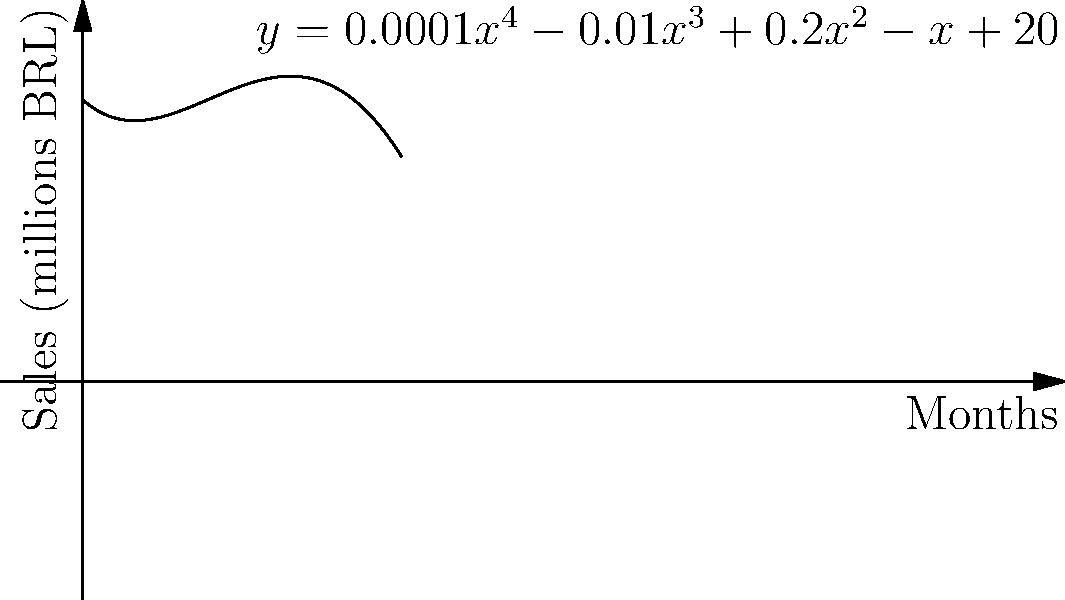As the marketing director overseeing the expansion in Brazil, you've modeled the projected sales (in millions of Brazilian Real) for the next 20 months using the quartic function $y = 0.0001x^4 - 0.01x^3 + 0.2x^2 - x + 20$, where $x$ represents the number of months since the start of operations. At which month do you expect to see the lowest sales, and what is the approximate sales value at that point? To find the month with the lowest sales and its corresponding value, we need to follow these steps:

1) The lowest point on the graph corresponds to the global minimum of the function.

2) To find the global minimum, we need to find where the derivative of the function equals zero:

   $\frac{dy}{dx} = 0.0004x^3 - 0.03x^2 + 0.4x - 1$

3) Set this equal to zero and solve:

   $0.0004x^3 - 0.03x^2 + 0.4x - 1 = 0$

4) This is a cubic equation and can be solved using a graphing calculator or computer algebra system. The solution relevant to our domain (0 to 20 months) is approximately $x = 5.8$.

5) Since we're dealing with whole months, we round this to 6 months.

6) To find the sales value at this point, we plug $x = 6$ into our original function:

   $y = 0.0001(6^4) - 0.01(6^3) + 0.2(6^2) - 6 + 20$
   $= 0.0001(1296) - 0.01(216) + 0.2(36) - 6 + 20$
   $= 0.1296 - 2.16 + 7.2 - 6 + 20$
   $= 19.1696$

7) Rounding to the nearest tenth of a million, we get 19.2 million BRL.
Answer: Month 6, approximately 19.2 million BRL 